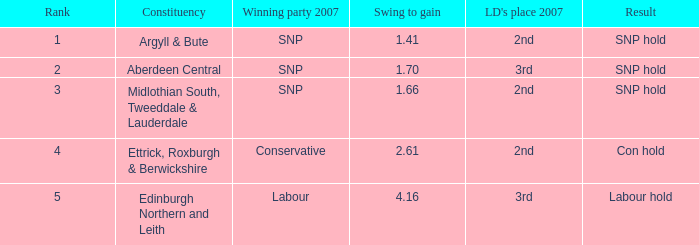What is the political division when the standing is fewer than 5 and the end is con hold? Ettrick, Roxburgh & Berwickshire. 